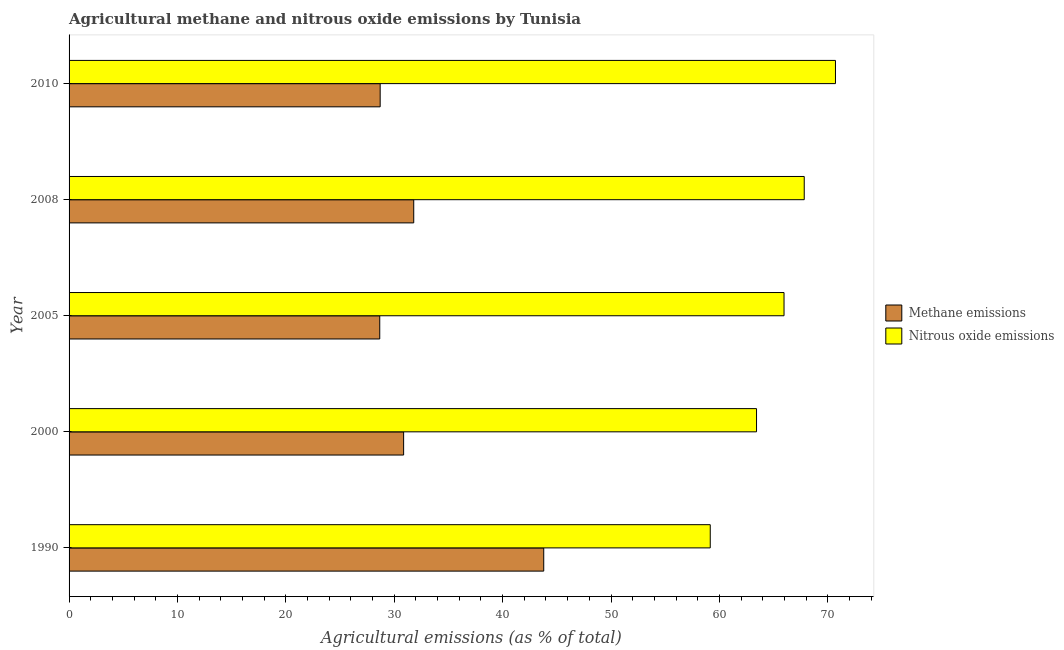How many different coloured bars are there?
Provide a short and direct response. 2. How many groups of bars are there?
Keep it short and to the point. 5. Are the number of bars per tick equal to the number of legend labels?
Your answer should be very brief. Yes. How many bars are there on the 3rd tick from the top?
Provide a short and direct response. 2. What is the label of the 2nd group of bars from the top?
Offer a terse response. 2008. What is the amount of methane emissions in 2005?
Give a very brief answer. 28.66. Across all years, what is the maximum amount of methane emissions?
Offer a terse response. 43.79. Across all years, what is the minimum amount of methane emissions?
Offer a very short reply. 28.66. In which year was the amount of nitrous oxide emissions maximum?
Your answer should be very brief. 2010. What is the total amount of methane emissions in the graph?
Provide a short and direct response. 163.82. What is the difference between the amount of nitrous oxide emissions in 1990 and that in 2000?
Your answer should be compact. -4.27. What is the difference between the amount of nitrous oxide emissions in 2008 and the amount of methane emissions in 1990?
Your answer should be compact. 24.03. What is the average amount of nitrous oxide emissions per year?
Provide a succinct answer. 65.42. In the year 2005, what is the difference between the amount of methane emissions and amount of nitrous oxide emissions?
Provide a succinct answer. -37.3. What is the ratio of the amount of methane emissions in 2008 to that in 2010?
Give a very brief answer. 1.11. What is the difference between the highest and the second highest amount of methane emissions?
Provide a succinct answer. 11.99. What is the difference between the highest and the lowest amount of nitrous oxide emissions?
Offer a very short reply. 11.55. Is the sum of the amount of methane emissions in 1990 and 2010 greater than the maximum amount of nitrous oxide emissions across all years?
Offer a very short reply. Yes. What does the 1st bar from the top in 2005 represents?
Your response must be concise. Nitrous oxide emissions. What does the 2nd bar from the bottom in 1990 represents?
Give a very brief answer. Nitrous oxide emissions. Are all the bars in the graph horizontal?
Provide a short and direct response. Yes. What is the difference between two consecutive major ticks on the X-axis?
Offer a very short reply. 10. Are the values on the major ticks of X-axis written in scientific E-notation?
Your answer should be compact. No. How many legend labels are there?
Keep it short and to the point. 2. How are the legend labels stacked?
Give a very brief answer. Vertical. What is the title of the graph?
Offer a terse response. Agricultural methane and nitrous oxide emissions by Tunisia. What is the label or title of the X-axis?
Give a very brief answer. Agricultural emissions (as % of total). What is the Agricultural emissions (as % of total) of Methane emissions in 1990?
Give a very brief answer. 43.79. What is the Agricultural emissions (as % of total) in Nitrous oxide emissions in 1990?
Provide a short and direct response. 59.15. What is the Agricultural emissions (as % of total) in Methane emissions in 2000?
Make the answer very short. 30.87. What is the Agricultural emissions (as % of total) of Nitrous oxide emissions in 2000?
Your answer should be very brief. 63.42. What is the Agricultural emissions (as % of total) in Methane emissions in 2005?
Offer a terse response. 28.66. What is the Agricultural emissions (as % of total) in Nitrous oxide emissions in 2005?
Your answer should be very brief. 65.96. What is the Agricultural emissions (as % of total) in Methane emissions in 2008?
Keep it short and to the point. 31.8. What is the Agricultural emissions (as % of total) of Nitrous oxide emissions in 2008?
Your answer should be very brief. 67.83. What is the Agricultural emissions (as % of total) in Methane emissions in 2010?
Ensure brevity in your answer.  28.7. What is the Agricultural emissions (as % of total) in Nitrous oxide emissions in 2010?
Make the answer very short. 70.71. Across all years, what is the maximum Agricultural emissions (as % of total) of Methane emissions?
Provide a succinct answer. 43.79. Across all years, what is the maximum Agricultural emissions (as % of total) of Nitrous oxide emissions?
Provide a succinct answer. 70.71. Across all years, what is the minimum Agricultural emissions (as % of total) in Methane emissions?
Make the answer very short. 28.66. Across all years, what is the minimum Agricultural emissions (as % of total) in Nitrous oxide emissions?
Provide a succinct answer. 59.15. What is the total Agricultural emissions (as % of total) of Methane emissions in the graph?
Your answer should be compact. 163.82. What is the total Agricultural emissions (as % of total) of Nitrous oxide emissions in the graph?
Ensure brevity in your answer.  327.08. What is the difference between the Agricultural emissions (as % of total) of Methane emissions in 1990 and that in 2000?
Give a very brief answer. 12.93. What is the difference between the Agricultural emissions (as % of total) in Nitrous oxide emissions in 1990 and that in 2000?
Provide a succinct answer. -4.27. What is the difference between the Agricultural emissions (as % of total) in Methane emissions in 1990 and that in 2005?
Offer a terse response. 15.13. What is the difference between the Agricultural emissions (as % of total) in Nitrous oxide emissions in 1990 and that in 2005?
Your response must be concise. -6.81. What is the difference between the Agricultural emissions (as % of total) of Methane emissions in 1990 and that in 2008?
Provide a short and direct response. 11.99. What is the difference between the Agricultural emissions (as % of total) of Nitrous oxide emissions in 1990 and that in 2008?
Make the answer very short. -8.67. What is the difference between the Agricultural emissions (as % of total) in Methane emissions in 1990 and that in 2010?
Provide a succinct answer. 15.09. What is the difference between the Agricultural emissions (as % of total) in Nitrous oxide emissions in 1990 and that in 2010?
Provide a short and direct response. -11.55. What is the difference between the Agricultural emissions (as % of total) of Methane emissions in 2000 and that in 2005?
Your answer should be compact. 2.2. What is the difference between the Agricultural emissions (as % of total) in Nitrous oxide emissions in 2000 and that in 2005?
Make the answer very short. -2.54. What is the difference between the Agricultural emissions (as % of total) in Methane emissions in 2000 and that in 2008?
Your answer should be very brief. -0.93. What is the difference between the Agricultural emissions (as % of total) of Nitrous oxide emissions in 2000 and that in 2008?
Ensure brevity in your answer.  -4.4. What is the difference between the Agricultural emissions (as % of total) of Methane emissions in 2000 and that in 2010?
Your response must be concise. 2.16. What is the difference between the Agricultural emissions (as % of total) of Nitrous oxide emissions in 2000 and that in 2010?
Make the answer very short. -7.28. What is the difference between the Agricultural emissions (as % of total) in Methane emissions in 2005 and that in 2008?
Give a very brief answer. -3.14. What is the difference between the Agricultural emissions (as % of total) of Nitrous oxide emissions in 2005 and that in 2008?
Your answer should be very brief. -1.86. What is the difference between the Agricultural emissions (as % of total) of Methane emissions in 2005 and that in 2010?
Keep it short and to the point. -0.04. What is the difference between the Agricultural emissions (as % of total) in Nitrous oxide emissions in 2005 and that in 2010?
Keep it short and to the point. -4.75. What is the difference between the Agricultural emissions (as % of total) of Methane emissions in 2008 and that in 2010?
Keep it short and to the point. 3.1. What is the difference between the Agricultural emissions (as % of total) in Nitrous oxide emissions in 2008 and that in 2010?
Give a very brief answer. -2.88. What is the difference between the Agricultural emissions (as % of total) of Methane emissions in 1990 and the Agricultural emissions (as % of total) of Nitrous oxide emissions in 2000?
Your answer should be compact. -19.63. What is the difference between the Agricultural emissions (as % of total) in Methane emissions in 1990 and the Agricultural emissions (as % of total) in Nitrous oxide emissions in 2005?
Your response must be concise. -22.17. What is the difference between the Agricultural emissions (as % of total) in Methane emissions in 1990 and the Agricultural emissions (as % of total) in Nitrous oxide emissions in 2008?
Provide a succinct answer. -24.03. What is the difference between the Agricultural emissions (as % of total) in Methane emissions in 1990 and the Agricultural emissions (as % of total) in Nitrous oxide emissions in 2010?
Ensure brevity in your answer.  -26.91. What is the difference between the Agricultural emissions (as % of total) in Methane emissions in 2000 and the Agricultural emissions (as % of total) in Nitrous oxide emissions in 2005?
Ensure brevity in your answer.  -35.1. What is the difference between the Agricultural emissions (as % of total) of Methane emissions in 2000 and the Agricultural emissions (as % of total) of Nitrous oxide emissions in 2008?
Provide a short and direct response. -36.96. What is the difference between the Agricultural emissions (as % of total) of Methane emissions in 2000 and the Agricultural emissions (as % of total) of Nitrous oxide emissions in 2010?
Your answer should be compact. -39.84. What is the difference between the Agricultural emissions (as % of total) of Methane emissions in 2005 and the Agricultural emissions (as % of total) of Nitrous oxide emissions in 2008?
Offer a terse response. -39.16. What is the difference between the Agricultural emissions (as % of total) of Methane emissions in 2005 and the Agricultural emissions (as % of total) of Nitrous oxide emissions in 2010?
Your response must be concise. -42.04. What is the difference between the Agricultural emissions (as % of total) of Methane emissions in 2008 and the Agricultural emissions (as % of total) of Nitrous oxide emissions in 2010?
Ensure brevity in your answer.  -38.91. What is the average Agricultural emissions (as % of total) in Methane emissions per year?
Give a very brief answer. 32.76. What is the average Agricultural emissions (as % of total) in Nitrous oxide emissions per year?
Your answer should be compact. 65.42. In the year 1990, what is the difference between the Agricultural emissions (as % of total) in Methane emissions and Agricultural emissions (as % of total) in Nitrous oxide emissions?
Make the answer very short. -15.36. In the year 2000, what is the difference between the Agricultural emissions (as % of total) of Methane emissions and Agricultural emissions (as % of total) of Nitrous oxide emissions?
Your response must be concise. -32.56. In the year 2005, what is the difference between the Agricultural emissions (as % of total) in Methane emissions and Agricultural emissions (as % of total) in Nitrous oxide emissions?
Offer a terse response. -37.3. In the year 2008, what is the difference between the Agricultural emissions (as % of total) in Methane emissions and Agricultural emissions (as % of total) in Nitrous oxide emissions?
Give a very brief answer. -36.03. In the year 2010, what is the difference between the Agricultural emissions (as % of total) in Methane emissions and Agricultural emissions (as % of total) in Nitrous oxide emissions?
Provide a succinct answer. -42.01. What is the ratio of the Agricultural emissions (as % of total) of Methane emissions in 1990 to that in 2000?
Offer a terse response. 1.42. What is the ratio of the Agricultural emissions (as % of total) in Nitrous oxide emissions in 1990 to that in 2000?
Provide a short and direct response. 0.93. What is the ratio of the Agricultural emissions (as % of total) in Methane emissions in 1990 to that in 2005?
Your response must be concise. 1.53. What is the ratio of the Agricultural emissions (as % of total) of Nitrous oxide emissions in 1990 to that in 2005?
Provide a succinct answer. 0.9. What is the ratio of the Agricultural emissions (as % of total) in Methane emissions in 1990 to that in 2008?
Give a very brief answer. 1.38. What is the ratio of the Agricultural emissions (as % of total) in Nitrous oxide emissions in 1990 to that in 2008?
Your response must be concise. 0.87. What is the ratio of the Agricultural emissions (as % of total) in Methane emissions in 1990 to that in 2010?
Give a very brief answer. 1.53. What is the ratio of the Agricultural emissions (as % of total) in Nitrous oxide emissions in 1990 to that in 2010?
Provide a succinct answer. 0.84. What is the ratio of the Agricultural emissions (as % of total) in Methane emissions in 2000 to that in 2005?
Provide a succinct answer. 1.08. What is the ratio of the Agricultural emissions (as % of total) of Nitrous oxide emissions in 2000 to that in 2005?
Keep it short and to the point. 0.96. What is the ratio of the Agricultural emissions (as % of total) of Methane emissions in 2000 to that in 2008?
Offer a very short reply. 0.97. What is the ratio of the Agricultural emissions (as % of total) of Nitrous oxide emissions in 2000 to that in 2008?
Offer a very short reply. 0.94. What is the ratio of the Agricultural emissions (as % of total) of Methane emissions in 2000 to that in 2010?
Your response must be concise. 1.08. What is the ratio of the Agricultural emissions (as % of total) in Nitrous oxide emissions in 2000 to that in 2010?
Provide a succinct answer. 0.9. What is the ratio of the Agricultural emissions (as % of total) of Methane emissions in 2005 to that in 2008?
Offer a very short reply. 0.9. What is the ratio of the Agricultural emissions (as % of total) in Nitrous oxide emissions in 2005 to that in 2008?
Give a very brief answer. 0.97. What is the ratio of the Agricultural emissions (as % of total) of Methane emissions in 2005 to that in 2010?
Ensure brevity in your answer.  1. What is the ratio of the Agricultural emissions (as % of total) of Nitrous oxide emissions in 2005 to that in 2010?
Give a very brief answer. 0.93. What is the ratio of the Agricultural emissions (as % of total) in Methane emissions in 2008 to that in 2010?
Offer a terse response. 1.11. What is the ratio of the Agricultural emissions (as % of total) of Nitrous oxide emissions in 2008 to that in 2010?
Offer a very short reply. 0.96. What is the difference between the highest and the second highest Agricultural emissions (as % of total) in Methane emissions?
Offer a terse response. 11.99. What is the difference between the highest and the second highest Agricultural emissions (as % of total) of Nitrous oxide emissions?
Ensure brevity in your answer.  2.88. What is the difference between the highest and the lowest Agricultural emissions (as % of total) of Methane emissions?
Provide a succinct answer. 15.13. What is the difference between the highest and the lowest Agricultural emissions (as % of total) in Nitrous oxide emissions?
Your response must be concise. 11.55. 